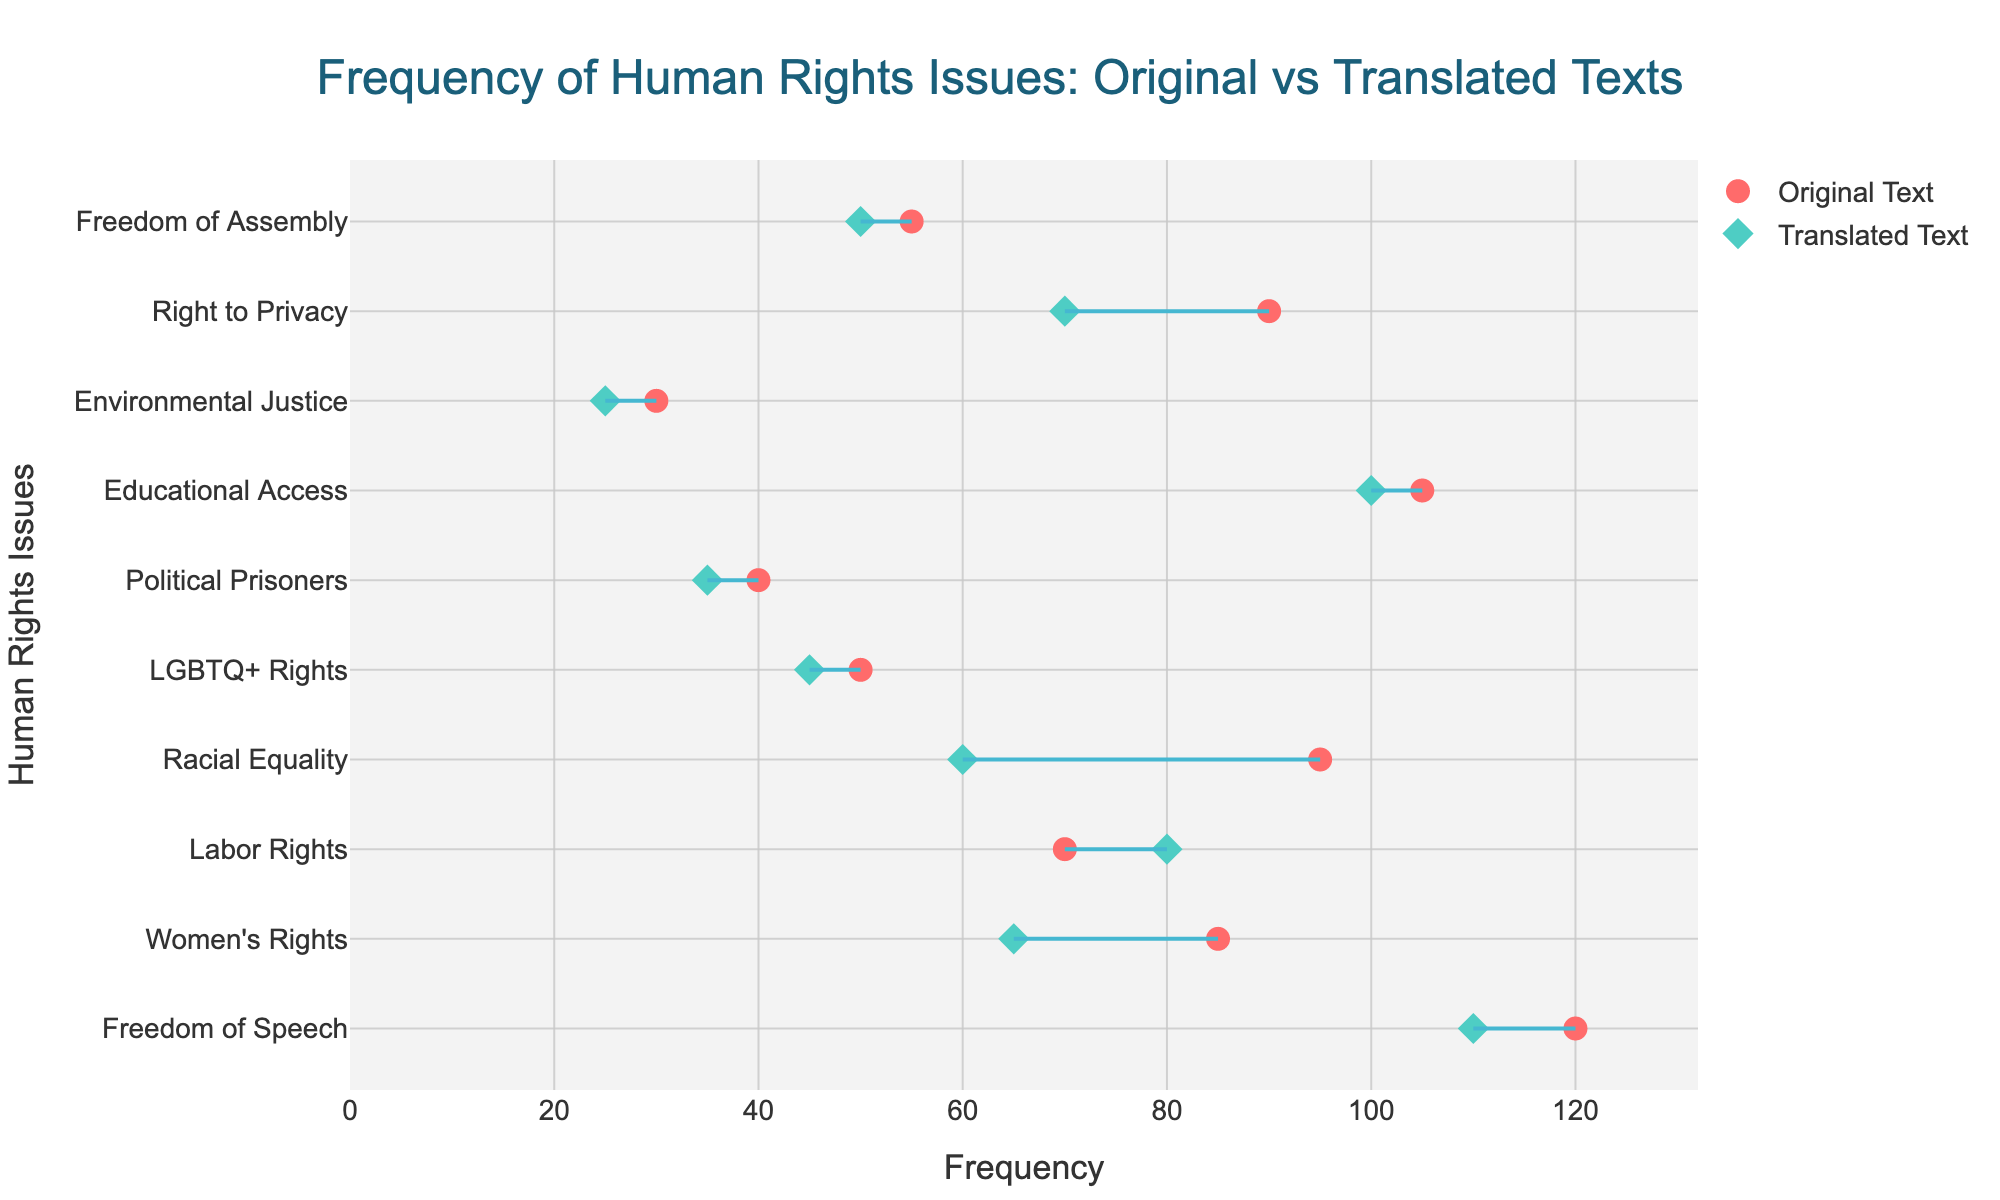What's the title of the plot? The title of the plot is typically found at the top of the figure, often formatted in a larger and bolder font. In this case, it is placed in the center.
Answer: Frequency of Human Rights Issues: Original vs Translated Texts What are the colors used for Original Text and Translated Text markers? The colors are distinguishable by looking at the markers in the figure's legend. The Original Text markers are in a red color, and the Translated Text markers are in a teal color.
Answer: Red and teal Which human rights issue has the highest frequency in the original text? Identify the human rights issue with the highest marker position on the x-axis among the Original Text markers. "Freedom of Speech" has the highest value at 120.
Answer: Freedom of Speech By how much does the frequency of references to Racial Equality differ between the original and translated texts? Locate "Racial Equality" on the y-axis and note the frequencies for both the Original Text (95) and Translated Text (60). Calculate the difference: 95 - 60 = 35.
Answer: 35 Which human rights issue shows an increase in frequency from the original to the translated texts? Compare the position of markers for each issue. "Labor Rights" has an Original Text frequency of 70 and a Translated Text frequency of 80, showing an increase.
Answer: Labor Rights What is the average frequency of Original Text references for Women's Rights and Educational Access? Find the frequencies for Women's Rights (85) and Educational Access (105), sum them (85 + 105 = 190), then divide by 2 for the average: 190/2 = 95.
Answer: 95 How many human rights issues have a higher frequency in the original text compared to the translated text? Compare each pair of markers on the x-axis for the Original Text and Translated Text. Count the instances where the Original Text has a higher frequency. There are seven such issues (Freedom of Speech, Women's Rights, Racial Equality, LGBTQ+ Rights, Political Prisoners, Right to Privacy, Environmental Justice).
Answer: 7 Which human rights issue shows the least difference in frequency between the original and translated texts? Calculate the differences between the frequencies for each issue and find the smallest. "Political Prisoners" shows a difference of 5 (40 - 35).
Answer: Political Prisoners What is the frequency of Right to Privacy in translated texts? Locate "Right to Privacy" on the y-axis and check its frequency on the Translated Text marker.
Answer: 70 